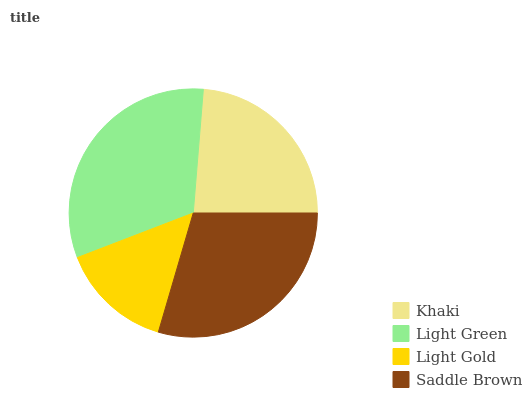Is Light Gold the minimum?
Answer yes or no. Yes. Is Light Green the maximum?
Answer yes or no. Yes. Is Light Green the minimum?
Answer yes or no. No. Is Light Gold the maximum?
Answer yes or no. No. Is Light Green greater than Light Gold?
Answer yes or no. Yes. Is Light Gold less than Light Green?
Answer yes or no. Yes. Is Light Gold greater than Light Green?
Answer yes or no. No. Is Light Green less than Light Gold?
Answer yes or no. No. Is Saddle Brown the high median?
Answer yes or no. Yes. Is Khaki the low median?
Answer yes or no. Yes. Is Khaki the high median?
Answer yes or no. No. Is Saddle Brown the low median?
Answer yes or no. No. 